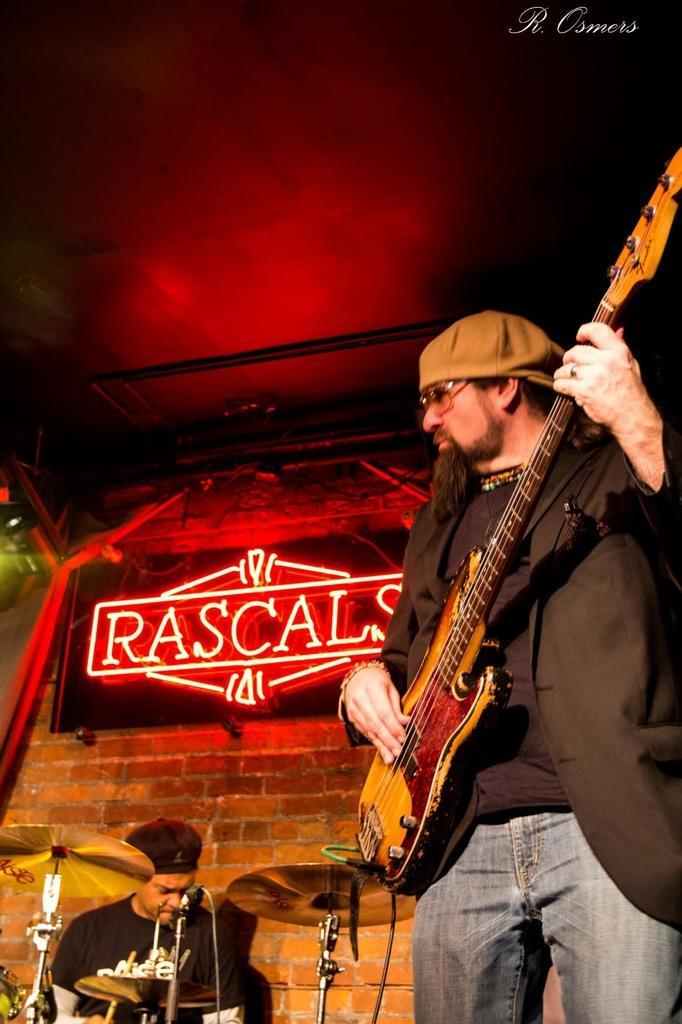Can you describe this image briefly? In this image we can see a man is standing and playing the guitar, and at back a person is sitting and playing the drums, and at back here is the wall made of bricks, and at above here is the roof. 